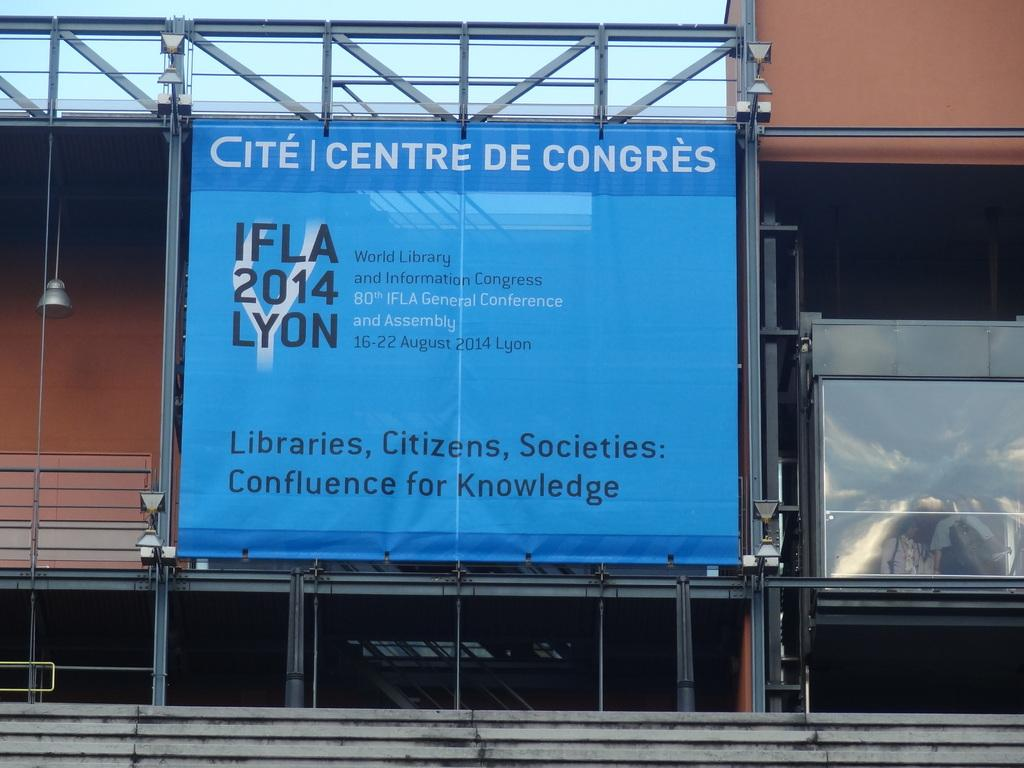<image>
Describe the image concisely. Centre De Congres IFLA 2014 Lyon poster for knowledge 